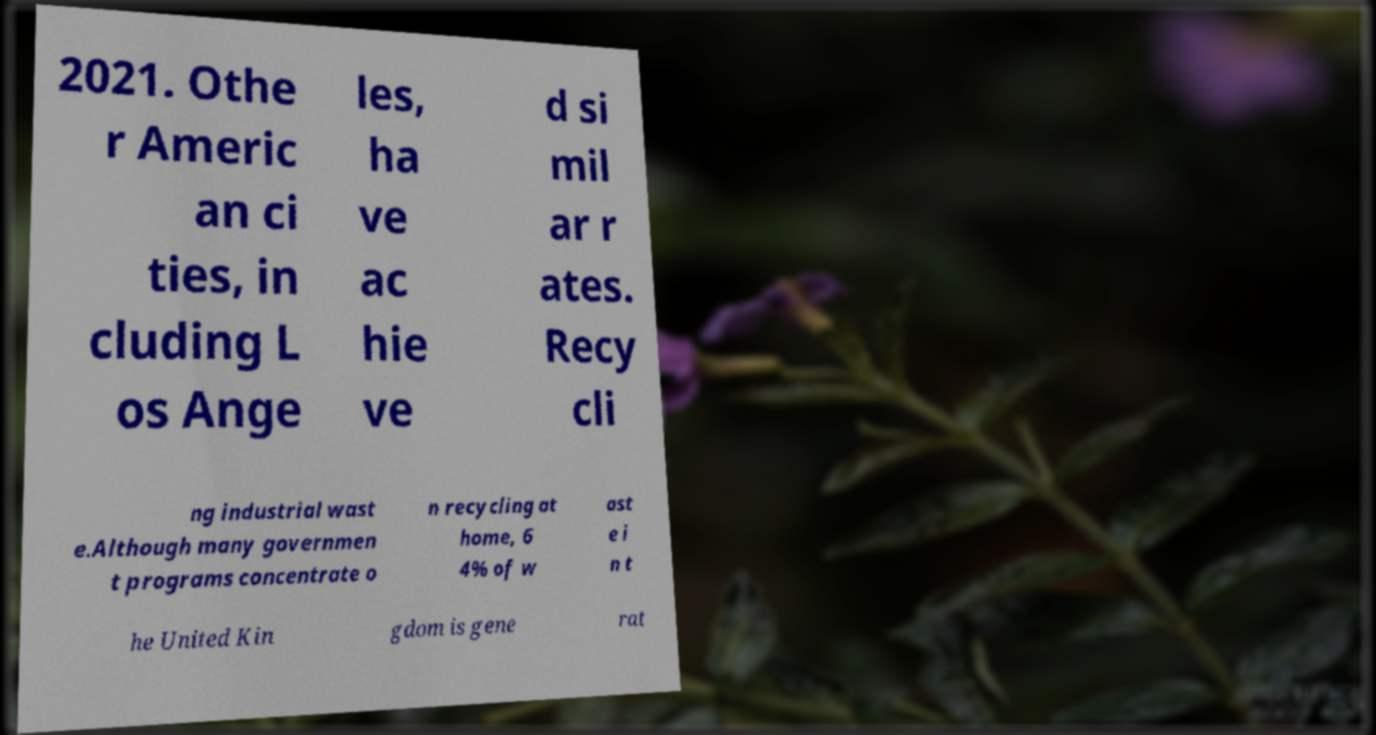I need the written content from this picture converted into text. Can you do that? 2021. Othe r Americ an ci ties, in cluding L os Ange les, ha ve ac hie ve d si mil ar r ates. Recy cli ng industrial wast e.Although many governmen t programs concentrate o n recycling at home, 6 4% of w ast e i n t he United Kin gdom is gene rat 